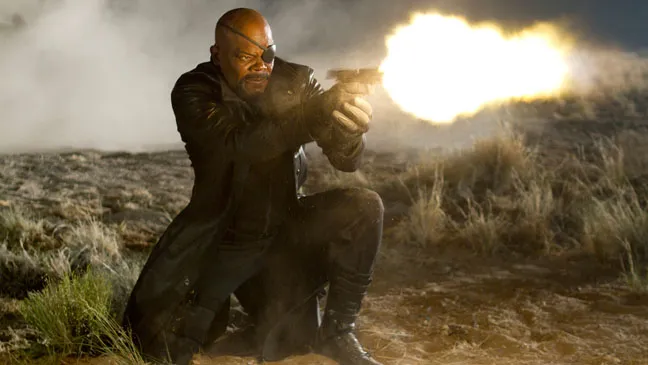Who could be his adversaries in this scene? Given the intense and dangerous vibe of this scene, his adversaries could range from a group of skilled mercenaries to menacing alien invaders. In the context of a superhero world, they might be formidable supervillains or a rogue faction equipped with high-tech weaponry. Their exact nature could be hinted at by elements such as tactical gear, otherworldly glow, or even remnants of advanced machinery scattered around the environment. Each potential adversary scenario highlights a different aspect of his diverse skill set and unyielding resolve in the face of danger. 